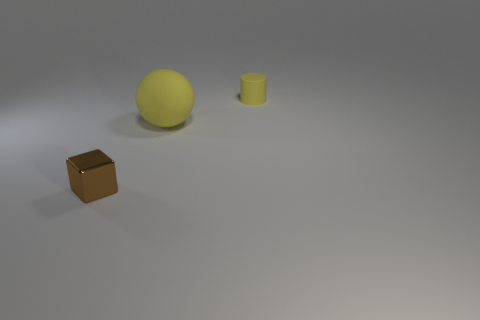Is there any other thing that has the same material as the brown block?
Make the answer very short. No. Is there a purple rubber object of the same size as the yellow rubber ball?
Provide a succinct answer. No. What shape is the object that is the same color as the small cylinder?
Provide a succinct answer. Sphere. What number of purple cylinders have the same size as the brown object?
Your answer should be compact. 0. There is a cube that is to the left of the large yellow sphere; does it have the same size as the yellow matte object that is on the left side of the rubber cylinder?
Give a very brief answer. No. How many objects are either yellow rubber objects or rubber things that are in front of the yellow cylinder?
Provide a succinct answer. 2. What is the color of the block?
Provide a short and direct response. Brown. What material is the small object that is in front of the yellow rubber thing in front of the small thing that is to the right of the block?
Make the answer very short. Metal. What size is the cylinder that is the same material as the yellow ball?
Make the answer very short. Small. Is there a small rubber cylinder that has the same color as the big matte thing?
Offer a terse response. Yes. 